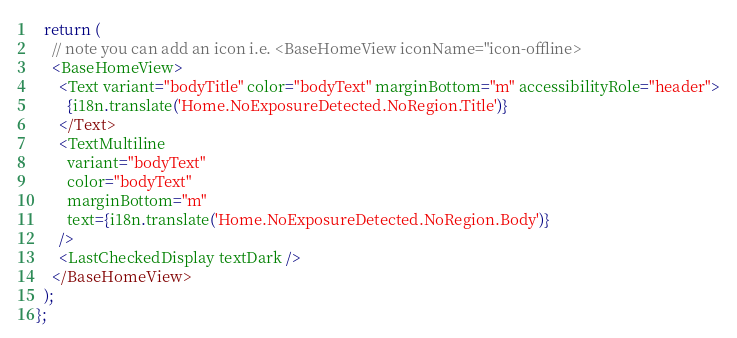Convert code to text. <code><loc_0><loc_0><loc_500><loc_500><_TypeScript_>  return (
    // note you can add an icon i.e. <BaseHomeView iconName="icon-offline>
    <BaseHomeView>
      <Text variant="bodyTitle" color="bodyText" marginBottom="m" accessibilityRole="header">
        {i18n.translate('Home.NoExposureDetected.NoRegion.Title')}
      </Text>
      <TextMultiline
        variant="bodyText"
        color="bodyText"
        marginBottom="m"
        text={i18n.translate('Home.NoExposureDetected.NoRegion.Body')}
      />
      <LastCheckedDisplay textDark />
    </BaseHomeView>
  );
};
</code> 